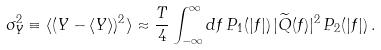Convert formula to latex. <formula><loc_0><loc_0><loc_500><loc_500>\sigma _ { Y } ^ { 2 } \equiv \langle ( Y - \langle Y \rangle ) ^ { 2 } \rangle \approx \frac { T } { 4 } \int _ { - \infty } ^ { \infty } d f \, P _ { 1 } ( | f | ) \, | \widetilde { Q } ( f ) | ^ { 2 } \, P _ { 2 } ( | f | ) \, .</formula> 